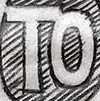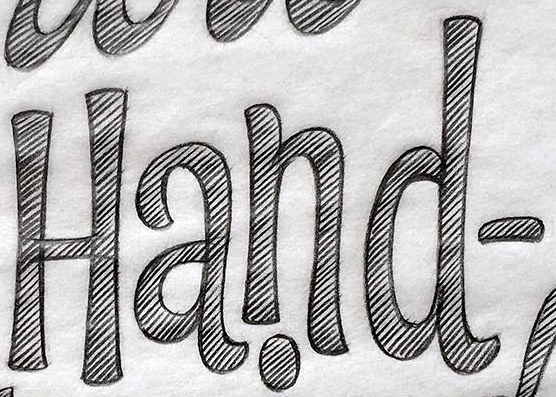Read the text content from these images in order, separated by a semicolon. TO; Hand- 